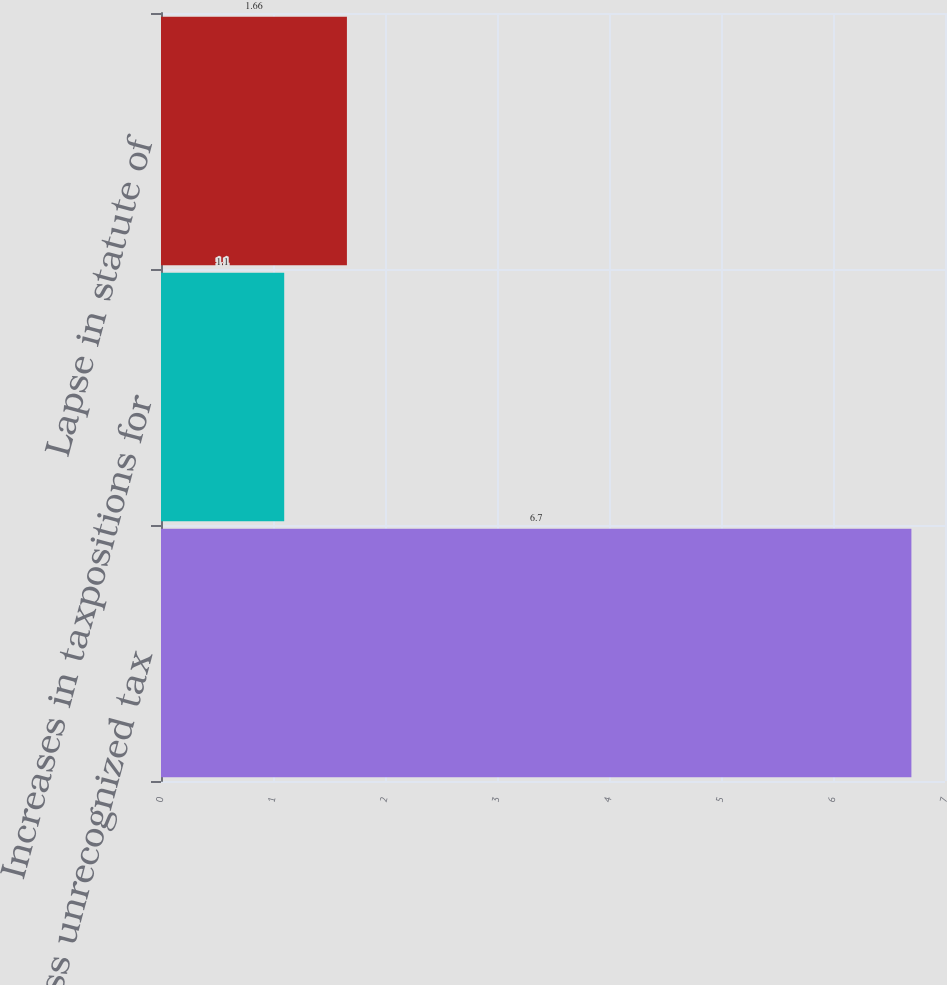Convert chart to OTSL. <chart><loc_0><loc_0><loc_500><loc_500><bar_chart><fcel>Gross unrecognized tax<fcel>Increases in taxpositions for<fcel>Lapse in statute of<nl><fcel>6.7<fcel>1.1<fcel>1.66<nl></chart> 